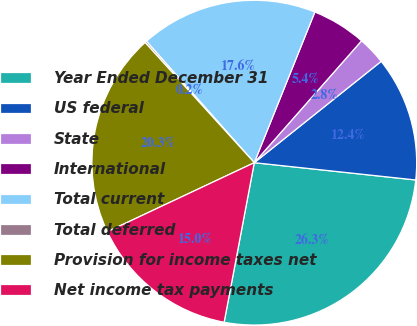Convert chart. <chart><loc_0><loc_0><loc_500><loc_500><pie_chart><fcel>Year Ended December 31<fcel>US federal<fcel>State<fcel>International<fcel>Total current<fcel>Total deferred<fcel>Provision for income taxes net<fcel>Net income tax payments<nl><fcel>26.27%<fcel>12.42%<fcel>2.79%<fcel>5.4%<fcel>17.64%<fcel>0.18%<fcel>20.25%<fcel>15.03%<nl></chart> 